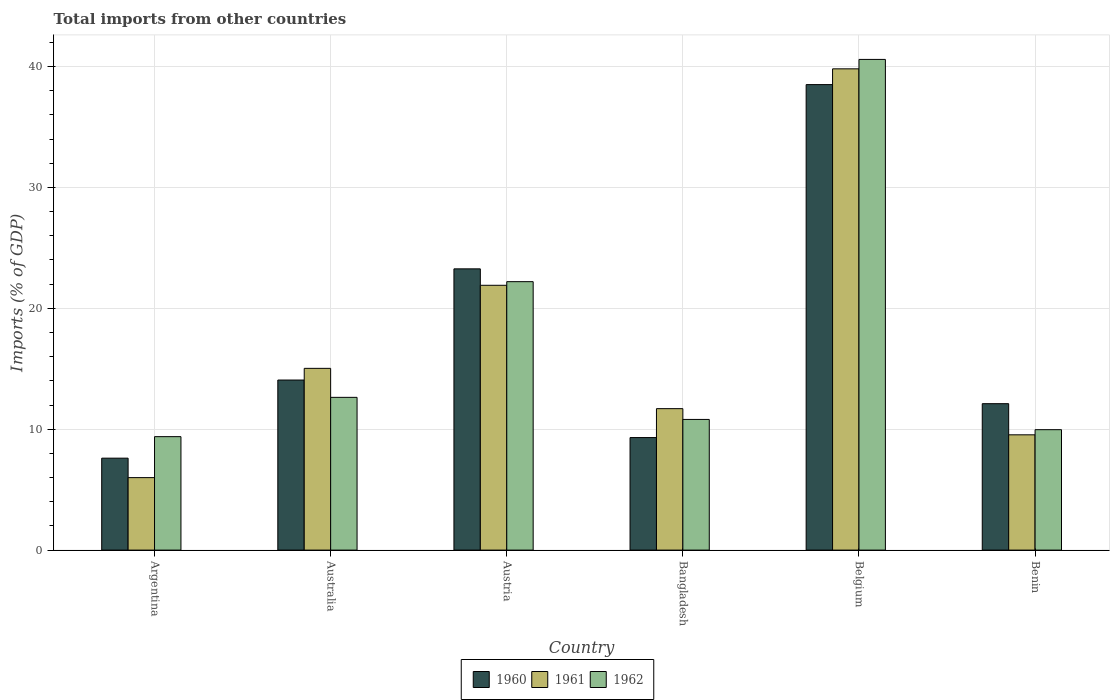Are the number of bars on each tick of the X-axis equal?
Your answer should be very brief. Yes. How many bars are there on the 1st tick from the right?
Give a very brief answer. 3. What is the label of the 5th group of bars from the left?
Your response must be concise. Belgium. In how many cases, is the number of bars for a given country not equal to the number of legend labels?
Your response must be concise. 0. What is the total imports in 1960 in Australia?
Give a very brief answer. 14.07. Across all countries, what is the maximum total imports in 1961?
Keep it short and to the point. 39.81. Across all countries, what is the minimum total imports in 1960?
Ensure brevity in your answer.  7.6. In which country was the total imports in 1962 minimum?
Your answer should be compact. Argentina. What is the total total imports in 1961 in the graph?
Offer a very short reply. 103.97. What is the difference between the total imports in 1960 in Bangladesh and that in Belgium?
Your response must be concise. -29.19. What is the difference between the total imports in 1962 in Australia and the total imports in 1961 in Argentina?
Offer a very short reply. 6.64. What is the average total imports in 1960 per country?
Give a very brief answer. 17.48. What is the difference between the total imports of/in 1961 and total imports of/in 1962 in Belgium?
Your answer should be compact. -0.78. In how many countries, is the total imports in 1962 greater than 4 %?
Ensure brevity in your answer.  6. What is the ratio of the total imports in 1962 in Argentina to that in Belgium?
Keep it short and to the point. 0.23. Is the total imports in 1961 in Austria less than that in Bangladesh?
Your answer should be very brief. No. Is the difference between the total imports in 1961 in Argentina and Benin greater than the difference between the total imports in 1962 in Argentina and Benin?
Your response must be concise. No. What is the difference between the highest and the second highest total imports in 1961?
Offer a very short reply. -6.87. What is the difference between the highest and the lowest total imports in 1961?
Your response must be concise. 33.81. In how many countries, is the total imports in 1962 greater than the average total imports in 1962 taken over all countries?
Make the answer very short. 2. Is the sum of the total imports in 1961 in Australia and Austria greater than the maximum total imports in 1962 across all countries?
Your answer should be compact. No. What does the 3rd bar from the left in Bangladesh represents?
Provide a short and direct response. 1962. What does the 2nd bar from the right in Austria represents?
Your answer should be compact. 1961. Is it the case that in every country, the sum of the total imports in 1960 and total imports in 1961 is greater than the total imports in 1962?
Keep it short and to the point. Yes. What is the difference between two consecutive major ticks on the Y-axis?
Your answer should be compact. 10. Are the values on the major ticks of Y-axis written in scientific E-notation?
Offer a terse response. No. Does the graph contain any zero values?
Provide a succinct answer. No. Does the graph contain grids?
Offer a terse response. Yes. Where does the legend appear in the graph?
Keep it short and to the point. Bottom center. How many legend labels are there?
Your answer should be compact. 3. What is the title of the graph?
Make the answer very short. Total imports from other countries. What is the label or title of the X-axis?
Your answer should be compact. Country. What is the label or title of the Y-axis?
Give a very brief answer. Imports (% of GDP). What is the Imports (% of GDP) in 1960 in Argentina?
Offer a terse response. 7.6. What is the Imports (% of GDP) of 1961 in Argentina?
Your answer should be compact. 5.99. What is the Imports (% of GDP) in 1962 in Argentina?
Your answer should be compact. 9.38. What is the Imports (% of GDP) of 1960 in Australia?
Give a very brief answer. 14.07. What is the Imports (% of GDP) in 1961 in Australia?
Provide a short and direct response. 15.03. What is the Imports (% of GDP) of 1962 in Australia?
Your response must be concise. 12.63. What is the Imports (% of GDP) of 1960 in Austria?
Provide a succinct answer. 23.26. What is the Imports (% of GDP) in 1961 in Austria?
Provide a short and direct response. 21.9. What is the Imports (% of GDP) of 1962 in Austria?
Give a very brief answer. 22.2. What is the Imports (% of GDP) of 1960 in Bangladesh?
Your answer should be compact. 9.31. What is the Imports (% of GDP) in 1961 in Bangladesh?
Ensure brevity in your answer.  11.7. What is the Imports (% of GDP) of 1962 in Bangladesh?
Your answer should be compact. 10.81. What is the Imports (% of GDP) of 1960 in Belgium?
Make the answer very short. 38.5. What is the Imports (% of GDP) of 1961 in Belgium?
Offer a very short reply. 39.81. What is the Imports (% of GDP) of 1962 in Belgium?
Give a very brief answer. 40.58. What is the Imports (% of GDP) in 1960 in Benin?
Offer a very short reply. 12.11. What is the Imports (% of GDP) of 1961 in Benin?
Keep it short and to the point. 9.53. What is the Imports (% of GDP) in 1962 in Benin?
Provide a short and direct response. 9.96. Across all countries, what is the maximum Imports (% of GDP) of 1960?
Give a very brief answer. 38.5. Across all countries, what is the maximum Imports (% of GDP) in 1961?
Offer a terse response. 39.81. Across all countries, what is the maximum Imports (% of GDP) of 1962?
Ensure brevity in your answer.  40.58. Across all countries, what is the minimum Imports (% of GDP) in 1960?
Ensure brevity in your answer.  7.6. Across all countries, what is the minimum Imports (% of GDP) of 1961?
Your answer should be very brief. 5.99. Across all countries, what is the minimum Imports (% of GDP) of 1962?
Offer a very short reply. 9.38. What is the total Imports (% of GDP) in 1960 in the graph?
Your response must be concise. 104.85. What is the total Imports (% of GDP) in 1961 in the graph?
Keep it short and to the point. 103.97. What is the total Imports (% of GDP) of 1962 in the graph?
Your answer should be compact. 105.57. What is the difference between the Imports (% of GDP) of 1960 in Argentina and that in Australia?
Offer a terse response. -6.46. What is the difference between the Imports (% of GDP) of 1961 in Argentina and that in Australia?
Make the answer very short. -9.04. What is the difference between the Imports (% of GDP) in 1962 in Argentina and that in Australia?
Ensure brevity in your answer.  -3.25. What is the difference between the Imports (% of GDP) of 1960 in Argentina and that in Austria?
Ensure brevity in your answer.  -15.66. What is the difference between the Imports (% of GDP) of 1961 in Argentina and that in Austria?
Give a very brief answer. -15.91. What is the difference between the Imports (% of GDP) of 1962 in Argentina and that in Austria?
Keep it short and to the point. -12.82. What is the difference between the Imports (% of GDP) of 1960 in Argentina and that in Bangladesh?
Your answer should be compact. -1.7. What is the difference between the Imports (% of GDP) in 1961 in Argentina and that in Bangladesh?
Give a very brief answer. -5.71. What is the difference between the Imports (% of GDP) in 1962 in Argentina and that in Bangladesh?
Make the answer very short. -1.42. What is the difference between the Imports (% of GDP) of 1960 in Argentina and that in Belgium?
Provide a short and direct response. -30.9. What is the difference between the Imports (% of GDP) of 1961 in Argentina and that in Belgium?
Provide a succinct answer. -33.81. What is the difference between the Imports (% of GDP) of 1962 in Argentina and that in Belgium?
Your response must be concise. -31.2. What is the difference between the Imports (% of GDP) of 1960 in Argentina and that in Benin?
Provide a succinct answer. -4.51. What is the difference between the Imports (% of GDP) of 1961 in Argentina and that in Benin?
Offer a very short reply. -3.54. What is the difference between the Imports (% of GDP) in 1962 in Argentina and that in Benin?
Give a very brief answer. -0.58. What is the difference between the Imports (% of GDP) in 1960 in Australia and that in Austria?
Give a very brief answer. -9.2. What is the difference between the Imports (% of GDP) of 1961 in Australia and that in Austria?
Provide a short and direct response. -6.87. What is the difference between the Imports (% of GDP) in 1962 in Australia and that in Austria?
Your answer should be compact. -9.57. What is the difference between the Imports (% of GDP) in 1960 in Australia and that in Bangladesh?
Provide a succinct answer. 4.76. What is the difference between the Imports (% of GDP) in 1961 in Australia and that in Bangladesh?
Give a very brief answer. 3.33. What is the difference between the Imports (% of GDP) in 1962 in Australia and that in Bangladesh?
Offer a terse response. 1.83. What is the difference between the Imports (% of GDP) of 1960 in Australia and that in Belgium?
Offer a very short reply. -24.43. What is the difference between the Imports (% of GDP) in 1961 in Australia and that in Belgium?
Provide a short and direct response. -24.77. What is the difference between the Imports (% of GDP) of 1962 in Australia and that in Belgium?
Make the answer very short. -27.95. What is the difference between the Imports (% of GDP) in 1960 in Australia and that in Benin?
Offer a very short reply. 1.96. What is the difference between the Imports (% of GDP) of 1961 in Australia and that in Benin?
Give a very brief answer. 5.5. What is the difference between the Imports (% of GDP) in 1962 in Australia and that in Benin?
Give a very brief answer. 2.67. What is the difference between the Imports (% of GDP) in 1960 in Austria and that in Bangladesh?
Provide a short and direct response. 13.95. What is the difference between the Imports (% of GDP) of 1961 in Austria and that in Bangladesh?
Offer a very short reply. 10.2. What is the difference between the Imports (% of GDP) of 1962 in Austria and that in Bangladesh?
Your response must be concise. 11.39. What is the difference between the Imports (% of GDP) in 1960 in Austria and that in Belgium?
Ensure brevity in your answer.  -15.24. What is the difference between the Imports (% of GDP) in 1961 in Austria and that in Belgium?
Make the answer very short. -17.9. What is the difference between the Imports (% of GDP) in 1962 in Austria and that in Belgium?
Provide a short and direct response. -18.38. What is the difference between the Imports (% of GDP) of 1960 in Austria and that in Benin?
Offer a terse response. 11.15. What is the difference between the Imports (% of GDP) in 1961 in Austria and that in Benin?
Your answer should be very brief. 12.37. What is the difference between the Imports (% of GDP) in 1962 in Austria and that in Benin?
Your answer should be very brief. 12.24. What is the difference between the Imports (% of GDP) of 1960 in Bangladesh and that in Belgium?
Ensure brevity in your answer.  -29.19. What is the difference between the Imports (% of GDP) in 1961 in Bangladesh and that in Belgium?
Make the answer very short. -28.11. What is the difference between the Imports (% of GDP) in 1962 in Bangladesh and that in Belgium?
Give a very brief answer. -29.78. What is the difference between the Imports (% of GDP) in 1960 in Bangladesh and that in Benin?
Offer a very short reply. -2.8. What is the difference between the Imports (% of GDP) of 1961 in Bangladesh and that in Benin?
Offer a terse response. 2.17. What is the difference between the Imports (% of GDP) of 1962 in Bangladesh and that in Benin?
Your answer should be very brief. 0.85. What is the difference between the Imports (% of GDP) of 1960 in Belgium and that in Benin?
Your answer should be compact. 26.39. What is the difference between the Imports (% of GDP) of 1961 in Belgium and that in Benin?
Your response must be concise. 30.27. What is the difference between the Imports (% of GDP) of 1962 in Belgium and that in Benin?
Provide a short and direct response. 30.63. What is the difference between the Imports (% of GDP) of 1960 in Argentina and the Imports (% of GDP) of 1961 in Australia?
Provide a succinct answer. -7.43. What is the difference between the Imports (% of GDP) of 1960 in Argentina and the Imports (% of GDP) of 1962 in Australia?
Your answer should be very brief. -5.03. What is the difference between the Imports (% of GDP) of 1961 in Argentina and the Imports (% of GDP) of 1962 in Australia?
Offer a very short reply. -6.64. What is the difference between the Imports (% of GDP) in 1960 in Argentina and the Imports (% of GDP) in 1961 in Austria?
Offer a very short reply. -14.3. What is the difference between the Imports (% of GDP) of 1960 in Argentina and the Imports (% of GDP) of 1962 in Austria?
Give a very brief answer. -14.6. What is the difference between the Imports (% of GDP) of 1961 in Argentina and the Imports (% of GDP) of 1962 in Austria?
Ensure brevity in your answer.  -16.21. What is the difference between the Imports (% of GDP) of 1960 in Argentina and the Imports (% of GDP) of 1961 in Bangladesh?
Keep it short and to the point. -4.1. What is the difference between the Imports (% of GDP) in 1960 in Argentina and the Imports (% of GDP) in 1962 in Bangladesh?
Provide a short and direct response. -3.2. What is the difference between the Imports (% of GDP) of 1961 in Argentina and the Imports (% of GDP) of 1962 in Bangladesh?
Keep it short and to the point. -4.81. What is the difference between the Imports (% of GDP) in 1960 in Argentina and the Imports (% of GDP) in 1961 in Belgium?
Offer a very short reply. -32.2. What is the difference between the Imports (% of GDP) in 1960 in Argentina and the Imports (% of GDP) in 1962 in Belgium?
Provide a succinct answer. -32.98. What is the difference between the Imports (% of GDP) of 1961 in Argentina and the Imports (% of GDP) of 1962 in Belgium?
Provide a short and direct response. -34.59. What is the difference between the Imports (% of GDP) in 1960 in Argentina and the Imports (% of GDP) in 1961 in Benin?
Your answer should be compact. -1.93. What is the difference between the Imports (% of GDP) in 1960 in Argentina and the Imports (% of GDP) in 1962 in Benin?
Provide a short and direct response. -2.36. What is the difference between the Imports (% of GDP) in 1961 in Argentina and the Imports (% of GDP) in 1962 in Benin?
Offer a terse response. -3.96. What is the difference between the Imports (% of GDP) of 1960 in Australia and the Imports (% of GDP) of 1961 in Austria?
Your answer should be compact. -7.84. What is the difference between the Imports (% of GDP) in 1960 in Australia and the Imports (% of GDP) in 1962 in Austria?
Keep it short and to the point. -8.14. What is the difference between the Imports (% of GDP) of 1961 in Australia and the Imports (% of GDP) of 1962 in Austria?
Give a very brief answer. -7.17. What is the difference between the Imports (% of GDP) of 1960 in Australia and the Imports (% of GDP) of 1961 in Bangladesh?
Your answer should be very brief. 2.37. What is the difference between the Imports (% of GDP) of 1960 in Australia and the Imports (% of GDP) of 1962 in Bangladesh?
Offer a very short reply. 3.26. What is the difference between the Imports (% of GDP) in 1961 in Australia and the Imports (% of GDP) in 1962 in Bangladesh?
Provide a succinct answer. 4.22. What is the difference between the Imports (% of GDP) of 1960 in Australia and the Imports (% of GDP) of 1961 in Belgium?
Keep it short and to the point. -25.74. What is the difference between the Imports (% of GDP) of 1960 in Australia and the Imports (% of GDP) of 1962 in Belgium?
Your answer should be very brief. -26.52. What is the difference between the Imports (% of GDP) of 1961 in Australia and the Imports (% of GDP) of 1962 in Belgium?
Offer a very short reply. -25.55. What is the difference between the Imports (% of GDP) in 1960 in Australia and the Imports (% of GDP) in 1961 in Benin?
Offer a terse response. 4.53. What is the difference between the Imports (% of GDP) of 1960 in Australia and the Imports (% of GDP) of 1962 in Benin?
Ensure brevity in your answer.  4.11. What is the difference between the Imports (% of GDP) in 1961 in Australia and the Imports (% of GDP) in 1962 in Benin?
Provide a short and direct response. 5.07. What is the difference between the Imports (% of GDP) of 1960 in Austria and the Imports (% of GDP) of 1961 in Bangladesh?
Offer a terse response. 11.56. What is the difference between the Imports (% of GDP) of 1960 in Austria and the Imports (% of GDP) of 1962 in Bangladesh?
Provide a succinct answer. 12.45. What is the difference between the Imports (% of GDP) in 1961 in Austria and the Imports (% of GDP) in 1962 in Bangladesh?
Ensure brevity in your answer.  11.09. What is the difference between the Imports (% of GDP) in 1960 in Austria and the Imports (% of GDP) in 1961 in Belgium?
Provide a short and direct response. -16.54. What is the difference between the Imports (% of GDP) of 1960 in Austria and the Imports (% of GDP) of 1962 in Belgium?
Provide a short and direct response. -17.32. What is the difference between the Imports (% of GDP) in 1961 in Austria and the Imports (% of GDP) in 1962 in Belgium?
Ensure brevity in your answer.  -18.68. What is the difference between the Imports (% of GDP) of 1960 in Austria and the Imports (% of GDP) of 1961 in Benin?
Offer a very short reply. 13.73. What is the difference between the Imports (% of GDP) in 1960 in Austria and the Imports (% of GDP) in 1962 in Benin?
Your response must be concise. 13.3. What is the difference between the Imports (% of GDP) of 1961 in Austria and the Imports (% of GDP) of 1962 in Benin?
Provide a succinct answer. 11.94. What is the difference between the Imports (% of GDP) of 1960 in Bangladesh and the Imports (% of GDP) of 1961 in Belgium?
Provide a succinct answer. -30.5. What is the difference between the Imports (% of GDP) of 1960 in Bangladesh and the Imports (% of GDP) of 1962 in Belgium?
Your answer should be compact. -31.28. What is the difference between the Imports (% of GDP) in 1961 in Bangladesh and the Imports (% of GDP) in 1962 in Belgium?
Offer a very short reply. -28.88. What is the difference between the Imports (% of GDP) in 1960 in Bangladesh and the Imports (% of GDP) in 1961 in Benin?
Your answer should be very brief. -0.23. What is the difference between the Imports (% of GDP) of 1960 in Bangladesh and the Imports (% of GDP) of 1962 in Benin?
Offer a very short reply. -0.65. What is the difference between the Imports (% of GDP) of 1961 in Bangladesh and the Imports (% of GDP) of 1962 in Benin?
Your answer should be very brief. 1.74. What is the difference between the Imports (% of GDP) of 1960 in Belgium and the Imports (% of GDP) of 1961 in Benin?
Provide a succinct answer. 28.97. What is the difference between the Imports (% of GDP) of 1960 in Belgium and the Imports (% of GDP) of 1962 in Benin?
Keep it short and to the point. 28.54. What is the difference between the Imports (% of GDP) of 1961 in Belgium and the Imports (% of GDP) of 1962 in Benin?
Give a very brief answer. 29.85. What is the average Imports (% of GDP) of 1960 per country?
Your response must be concise. 17.48. What is the average Imports (% of GDP) of 1961 per country?
Your response must be concise. 17.33. What is the average Imports (% of GDP) of 1962 per country?
Provide a short and direct response. 17.6. What is the difference between the Imports (% of GDP) in 1960 and Imports (% of GDP) in 1961 in Argentina?
Offer a terse response. 1.61. What is the difference between the Imports (% of GDP) of 1960 and Imports (% of GDP) of 1962 in Argentina?
Give a very brief answer. -1.78. What is the difference between the Imports (% of GDP) in 1961 and Imports (% of GDP) in 1962 in Argentina?
Offer a very short reply. -3.39. What is the difference between the Imports (% of GDP) of 1960 and Imports (% of GDP) of 1961 in Australia?
Offer a terse response. -0.97. What is the difference between the Imports (% of GDP) of 1960 and Imports (% of GDP) of 1962 in Australia?
Provide a short and direct response. 1.43. What is the difference between the Imports (% of GDP) of 1961 and Imports (% of GDP) of 1962 in Australia?
Ensure brevity in your answer.  2.4. What is the difference between the Imports (% of GDP) of 1960 and Imports (% of GDP) of 1961 in Austria?
Keep it short and to the point. 1.36. What is the difference between the Imports (% of GDP) in 1960 and Imports (% of GDP) in 1962 in Austria?
Provide a succinct answer. 1.06. What is the difference between the Imports (% of GDP) of 1961 and Imports (% of GDP) of 1962 in Austria?
Provide a short and direct response. -0.3. What is the difference between the Imports (% of GDP) in 1960 and Imports (% of GDP) in 1961 in Bangladesh?
Your response must be concise. -2.39. What is the difference between the Imports (% of GDP) of 1960 and Imports (% of GDP) of 1962 in Bangladesh?
Your answer should be very brief. -1.5. What is the difference between the Imports (% of GDP) in 1961 and Imports (% of GDP) in 1962 in Bangladesh?
Offer a very short reply. 0.89. What is the difference between the Imports (% of GDP) in 1960 and Imports (% of GDP) in 1961 in Belgium?
Offer a very short reply. -1.3. What is the difference between the Imports (% of GDP) of 1960 and Imports (% of GDP) of 1962 in Belgium?
Offer a very short reply. -2.08. What is the difference between the Imports (% of GDP) of 1961 and Imports (% of GDP) of 1962 in Belgium?
Ensure brevity in your answer.  -0.78. What is the difference between the Imports (% of GDP) of 1960 and Imports (% of GDP) of 1961 in Benin?
Ensure brevity in your answer.  2.58. What is the difference between the Imports (% of GDP) of 1960 and Imports (% of GDP) of 1962 in Benin?
Provide a short and direct response. 2.15. What is the difference between the Imports (% of GDP) of 1961 and Imports (% of GDP) of 1962 in Benin?
Ensure brevity in your answer.  -0.42. What is the ratio of the Imports (% of GDP) of 1960 in Argentina to that in Australia?
Offer a very short reply. 0.54. What is the ratio of the Imports (% of GDP) in 1961 in Argentina to that in Australia?
Ensure brevity in your answer.  0.4. What is the ratio of the Imports (% of GDP) in 1962 in Argentina to that in Australia?
Your response must be concise. 0.74. What is the ratio of the Imports (% of GDP) of 1960 in Argentina to that in Austria?
Offer a terse response. 0.33. What is the ratio of the Imports (% of GDP) of 1961 in Argentina to that in Austria?
Your answer should be compact. 0.27. What is the ratio of the Imports (% of GDP) of 1962 in Argentina to that in Austria?
Provide a short and direct response. 0.42. What is the ratio of the Imports (% of GDP) of 1960 in Argentina to that in Bangladesh?
Provide a succinct answer. 0.82. What is the ratio of the Imports (% of GDP) of 1961 in Argentina to that in Bangladesh?
Your answer should be compact. 0.51. What is the ratio of the Imports (% of GDP) in 1962 in Argentina to that in Bangladesh?
Give a very brief answer. 0.87. What is the ratio of the Imports (% of GDP) of 1960 in Argentina to that in Belgium?
Your answer should be compact. 0.2. What is the ratio of the Imports (% of GDP) of 1961 in Argentina to that in Belgium?
Provide a short and direct response. 0.15. What is the ratio of the Imports (% of GDP) of 1962 in Argentina to that in Belgium?
Provide a succinct answer. 0.23. What is the ratio of the Imports (% of GDP) in 1960 in Argentina to that in Benin?
Provide a succinct answer. 0.63. What is the ratio of the Imports (% of GDP) in 1961 in Argentina to that in Benin?
Offer a terse response. 0.63. What is the ratio of the Imports (% of GDP) of 1962 in Argentina to that in Benin?
Your answer should be compact. 0.94. What is the ratio of the Imports (% of GDP) in 1960 in Australia to that in Austria?
Provide a succinct answer. 0.6. What is the ratio of the Imports (% of GDP) in 1961 in Australia to that in Austria?
Offer a very short reply. 0.69. What is the ratio of the Imports (% of GDP) of 1962 in Australia to that in Austria?
Provide a succinct answer. 0.57. What is the ratio of the Imports (% of GDP) of 1960 in Australia to that in Bangladesh?
Offer a very short reply. 1.51. What is the ratio of the Imports (% of GDP) of 1961 in Australia to that in Bangladesh?
Ensure brevity in your answer.  1.28. What is the ratio of the Imports (% of GDP) of 1962 in Australia to that in Bangladesh?
Your answer should be compact. 1.17. What is the ratio of the Imports (% of GDP) of 1960 in Australia to that in Belgium?
Your response must be concise. 0.37. What is the ratio of the Imports (% of GDP) of 1961 in Australia to that in Belgium?
Provide a short and direct response. 0.38. What is the ratio of the Imports (% of GDP) of 1962 in Australia to that in Belgium?
Provide a short and direct response. 0.31. What is the ratio of the Imports (% of GDP) in 1960 in Australia to that in Benin?
Your answer should be very brief. 1.16. What is the ratio of the Imports (% of GDP) of 1961 in Australia to that in Benin?
Provide a succinct answer. 1.58. What is the ratio of the Imports (% of GDP) of 1962 in Australia to that in Benin?
Offer a very short reply. 1.27. What is the ratio of the Imports (% of GDP) of 1960 in Austria to that in Bangladesh?
Give a very brief answer. 2.5. What is the ratio of the Imports (% of GDP) of 1961 in Austria to that in Bangladesh?
Your answer should be compact. 1.87. What is the ratio of the Imports (% of GDP) in 1962 in Austria to that in Bangladesh?
Keep it short and to the point. 2.05. What is the ratio of the Imports (% of GDP) in 1960 in Austria to that in Belgium?
Keep it short and to the point. 0.6. What is the ratio of the Imports (% of GDP) in 1961 in Austria to that in Belgium?
Provide a short and direct response. 0.55. What is the ratio of the Imports (% of GDP) in 1962 in Austria to that in Belgium?
Your answer should be very brief. 0.55. What is the ratio of the Imports (% of GDP) in 1960 in Austria to that in Benin?
Offer a very short reply. 1.92. What is the ratio of the Imports (% of GDP) of 1961 in Austria to that in Benin?
Provide a succinct answer. 2.3. What is the ratio of the Imports (% of GDP) in 1962 in Austria to that in Benin?
Your answer should be very brief. 2.23. What is the ratio of the Imports (% of GDP) in 1960 in Bangladesh to that in Belgium?
Give a very brief answer. 0.24. What is the ratio of the Imports (% of GDP) of 1961 in Bangladesh to that in Belgium?
Ensure brevity in your answer.  0.29. What is the ratio of the Imports (% of GDP) in 1962 in Bangladesh to that in Belgium?
Provide a succinct answer. 0.27. What is the ratio of the Imports (% of GDP) of 1960 in Bangladesh to that in Benin?
Provide a short and direct response. 0.77. What is the ratio of the Imports (% of GDP) in 1961 in Bangladesh to that in Benin?
Keep it short and to the point. 1.23. What is the ratio of the Imports (% of GDP) of 1962 in Bangladesh to that in Benin?
Give a very brief answer. 1.09. What is the ratio of the Imports (% of GDP) in 1960 in Belgium to that in Benin?
Offer a terse response. 3.18. What is the ratio of the Imports (% of GDP) of 1961 in Belgium to that in Benin?
Keep it short and to the point. 4.17. What is the ratio of the Imports (% of GDP) of 1962 in Belgium to that in Benin?
Ensure brevity in your answer.  4.08. What is the difference between the highest and the second highest Imports (% of GDP) in 1960?
Offer a terse response. 15.24. What is the difference between the highest and the second highest Imports (% of GDP) in 1961?
Your response must be concise. 17.9. What is the difference between the highest and the second highest Imports (% of GDP) in 1962?
Your response must be concise. 18.38. What is the difference between the highest and the lowest Imports (% of GDP) of 1960?
Your response must be concise. 30.9. What is the difference between the highest and the lowest Imports (% of GDP) in 1961?
Ensure brevity in your answer.  33.81. What is the difference between the highest and the lowest Imports (% of GDP) of 1962?
Your answer should be very brief. 31.2. 